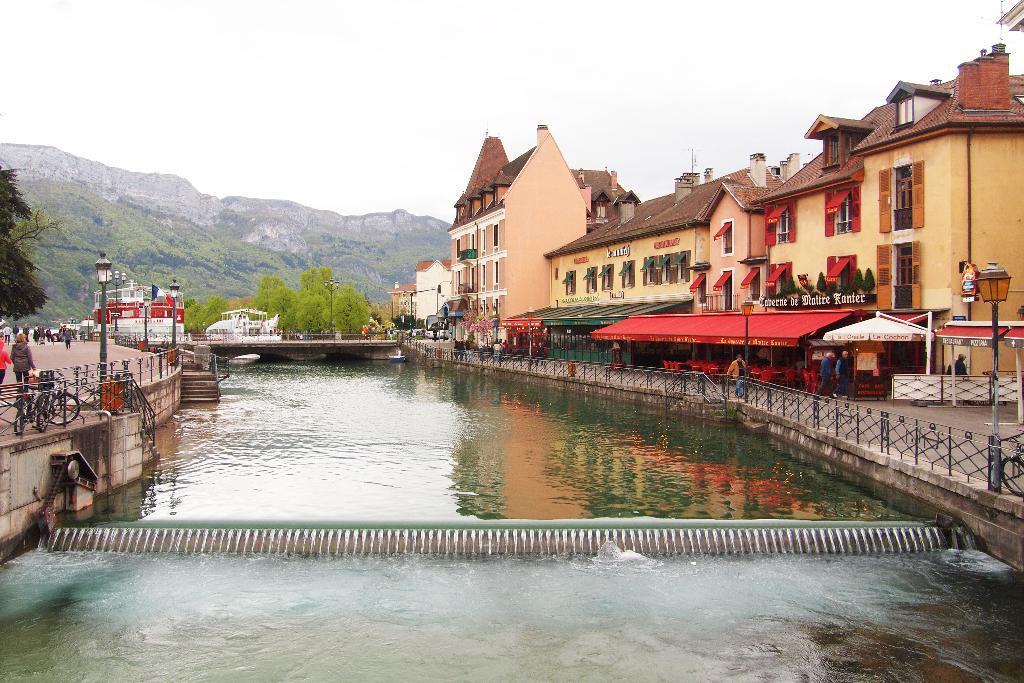Could you give a brief overview of what you see in this image? In the foreground of this picture, there is a canal to which on the both side there is a path to walk. In the background, there are buildings, tents, poles, trees, persons walking on the path, hill and the sky. 